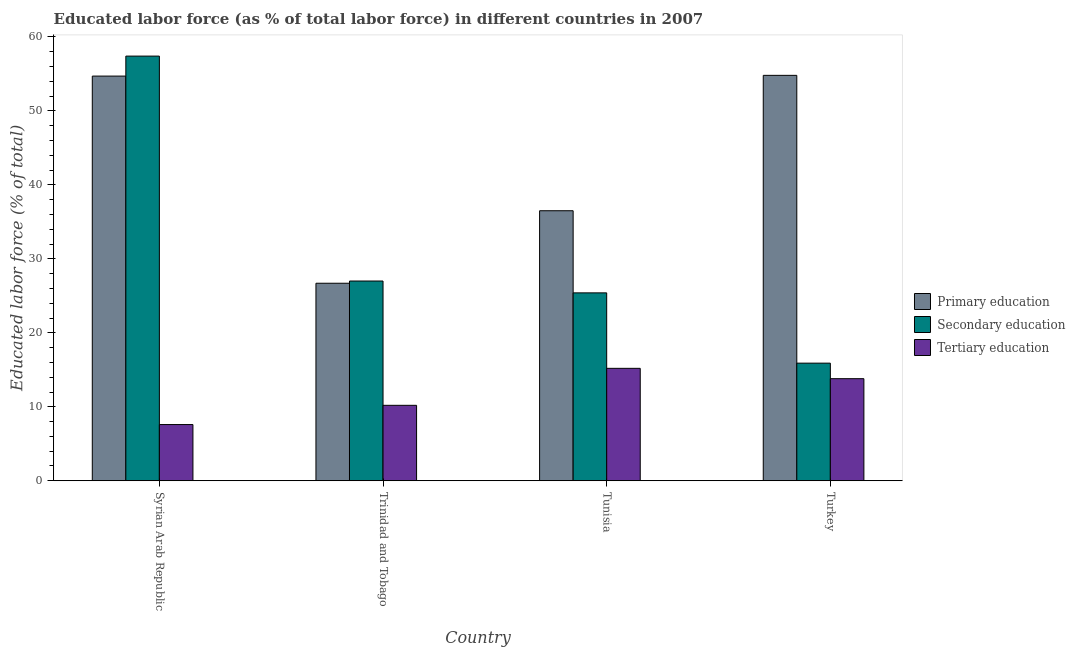How many different coloured bars are there?
Offer a terse response. 3. Are the number of bars per tick equal to the number of legend labels?
Keep it short and to the point. Yes. Are the number of bars on each tick of the X-axis equal?
Your answer should be compact. Yes. How many bars are there on the 4th tick from the left?
Your answer should be very brief. 3. What is the label of the 3rd group of bars from the left?
Your answer should be compact. Tunisia. In how many cases, is the number of bars for a given country not equal to the number of legend labels?
Offer a terse response. 0. What is the percentage of labor force who received primary education in Tunisia?
Your answer should be very brief. 36.5. Across all countries, what is the maximum percentage of labor force who received secondary education?
Offer a terse response. 57.4. Across all countries, what is the minimum percentage of labor force who received tertiary education?
Offer a terse response. 7.6. In which country was the percentage of labor force who received secondary education maximum?
Offer a very short reply. Syrian Arab Republic. What is the total percentage of labor force who received primary education in the graph?
Keep it short and to the point. 172.7. What is the difference between the percentage of labor force who received tertiary education in Trinidad and Tobago and that in Tunisia?
Offer a terse response. -5. What is the difference between the percentage of labor force who received primary education in Syrian Arab Republic and the percentage of labor force who received secondary education in Turkey?
Provide a succinct answer. 38.8. What is the average percentage of labor force who received secondary education per country?
Your answer should be compact. 31.43. What is the difference between the percentage of labor force who received secondary education and percentage of labor force who received primary education in Tunisia?
Provide a short and direct response. -11.1. In how many countries, is the percentage of labor force who received secondary education greater than 16 %?
Your answer should be very brief. 3. What is the ratio of the percentage of labor force who received primary education in Syrian Arab Republic to that in Trinidad and Tobago?
Keep it short and to the point. 2.05. Is the percentage of labor force who received tertiary education in Trinidad and Tobago less than that in Tunisia?
Offer a terse response. Yes. What is the difference between the highest and the second highest percentage of labor force who received primary education?
Your answer should be compact. 0.1. What is the difference between the highest and the lowest percentage of labor force who received primary education?
Your answer should be very brief. 28.1. In how many countries, is the percentage of labor force who received tertiary education greater than the average percentage of labor force who received tertiary education taken over all countries?
Your answer should be very brief. 2. Is the sum of the percentage of labor force who received secondary education in Tunisia and Turkey greater than the maximum percentage of labor force who received primary education across all countries?
Provide a short and direct response. No. What does the 2nd bar from the left in Trinidad and Tobago represents?
Provide a short and direct response. Secondary education. What does the 3rd bar from the right in Syrian Arab Republic represents?
Give a very brief answer. Primary education. Is it the case that in every country, the sum of the percentage of labor force who received primary education and percentage of labor force who received secondary education is greater than the percentage of labor force who received tertiary education?
Provide a short and direct response. Yes. How many bars are there?
Ensure brevity in your answer.  12. How many countries are there in the graph?
Provide a succinct answer. 4. Are the values on the major ticks of Y-axis written in scientific E-notation?
Keep it short and to the point. No. Where does the legend appear in the graph?
Your answer should be compact. Center right. How many legend labels are there?
Make the answer very short. 3. How are the legend labels stacked?
Provide a short and direct response. Vertical. What is the title of the graph?
Your response must be concise. Educated labor force (as % of total labor force) in different countries in 2007. What is the label or title of the Y-axis?
Provide a short and direct response. Educated labor force (% of total). What is the Educated labor force (% of total) in Primary education in Syrian Arab Republic?
Keep it short and to the point. 54.7. What is the Educated labor force (% of total) of Secondary education in Syrian Arab Republic?
Give a very brief answer. 57.4. What is the Educated labor force (% of total) in Tertiary education in Syrian Arab Republic?
Ensure brevity in your answer.  7.6. What is the Educated labor force (% of total) in Primary education in Trinidad and Tobago?
Make the answer very short. 26.7. What is the Educated labor force (% of total) in Tertiary education in Trinidad and Tobago?
Your response must be concise. 10.2. What is the Educated labor force (% of total) of Primary education in Tunisia?
Your response must be concise. 36.5. What is the Educated labor force (% of total) in Secondary education in Tunisia?
Give a very brief answer. 25.4. What is the Educated labor force (% of total) in Tertiary education in Tunisia?
Provide a short and direct response. 15.2. What is the Educated labor force (% of total) in Primary education in Turkey?
Make the answer very short. 54.8. What is the Educated labor force (% of total) of Secondary education in Turkey?
Your response must be concise. 15.9. What is the Educated labor force (% of total) in Tertiary education in Turkey?
Provide a succinct answer. 13.8. Across all countries, what is the maximum Educated labor force (% of total) in Primary education?
Your answer should be very brief. 54.8. Across all countries, what is the maximum Educated labor force (% of total) of Secondary education?
Give a very brief answer. 57.4. Across all countries, what is the maximum Educated labor force (% of total) in Tertiary education?
Provide a succinct answer. 15.2. Across all countries, what is the minimum Educated labor force (% of total) of Primary education?
Your response must be concise. 26.7. Across all countries, what is the minimum Educated labor force (% of total) of Secondary education?
Your response must be concise. 15.9. Across all countries, what is the minimum Educated labor force (% of total) in Tertiary education?
Ensure brevity in your answer.  7.6. What is the total Educated labor force (% of total) of Primary education in the graph?
Keep it short and to the point. 172.7. What is the total Educated labor force (% of total) of Secondary education in the graph?
Make the answer very short. 125.7. What is the total Educated labor force (% of total) of Tertiary education in the graph?
Offer a very short reply. 46.8. What is the difference between the Educated labor force (% of total) of Primary education in Syrian Arab Republic and that in Trinidad and Tobago?
Give a very brief answer. 28. What is the difference between the Educated labor force (% of total) in Secondary education in Syrian Arab Republic and that in Trinidad and Tobago?
Offer a very short reply. 30.4. What is the difference between the Educated labor force (% of total) of Tertiary education in Syrian Arab Republic and that in Trinidad and Tobago?
Ensure brevity in your answer.  -2.6. What is the difference between the Educated labor force (% of total) of Secondary education in Syrian Arab Republic and that in Tunisia?
Provide a short and direct response. 32. What is the difference between the Educated labor force (% of total) of Tertiary education in Syrian Arab Republic and that in Tunisia?
Your response must be concise. -7.6. What is the difference between the Educated labor force (% of total) in Secondary education in Syrian Arab Republic and that in Turkey?
Your response must be concise. 41.5. What is the difference between the Educated labor force (% of total) of Tertiary education in Trinidad and Tobago and that in Tunisia?
Provide a succinct answer. -5. What is the difference between the Educated labor force (% of total) of Primary education in Trinidad and Tobago and that in Turkey?
Provide a succinct answer. -28.1. What is the difference between the Educated labor force (% of total) of Secondary education in Trinidad and Tobago and that in Turkey?
Give a very brief answer. 11.1. What is the difference between the Educated labor force (% of total) of Tertiary education in Trinidad and Tobago and that in Turkey?
Offer a very short reply. -3.6. What is the difference between the Educated labor force (% of total) in Primary education in Tunisia and that in Turkey?
Keep it short and to the point. -18.3. What is the difference between the Educated labor force (% of total) of Secondary education in Tunisia and that in Turkey?
Your answer should be very brief. 9.5. What is the difference between the Educated labor force (% of total) of Primary education in Syrian Arab Republic and the Educated labor force (% of total) of Secondary education in Trinidad and Tobago?
Offer a very short reply. 27.7. What is the difference between the Educated labor force (% of total) of Primary education in Syrian Arab Republic and the Educated labor force (% of total) of Tertiary education in Trinidad and Tobago?
Make the answer very short. 44.5. What is the difference between the Educated labor force (% of total) of Secondary education in Syrian Arab Republic and the Educated labor force (% of total) of Tertiary education in Trinidad and Tobago?
Your answer should be compact. 47.2. What is the difference between the Educated labor force (% of total) in Primary education in Syrian Arab Republic and the Educated labor force (% of total) in Secondary education in Tunisia?
Offer a very short reply. 29.3. What is the difference between the Educated labor force (% of total) in Primary education in Syrian Arab Republic and the Educated labor force (% of total) in Tertiary education in Tunisia?
Offer a terse response. 39.5. What is the difference between the Educated labor force (% of total) in Secondary education in Syrian Arab Republic and the Educated labor force (% of total) in Tertiary education in Tunisia?
Make the answer very short. 42.2. What is the difference between the Educated labor force (% of total) in Primary education in Syrian Arab Republic and the Educated labor force (% of total) in Secondary education in Turkey?
Your answer should be very brief. 38.8. What is the difference between the Educated labor force (% of total) in Primary education in Syrian Arab Republic and the Educated labor force (% of total) in Tertiary education in Turkey?
Your response must be concise. 40.9. What is the difference between the Educated labor force (% of total) in Secondary education in Syrian Arab Republic and the Educated labor force (% of total) in Tertiary education in Turkey?
Give a very brief answer. 43.6. What is the difference between the Educated labor force (% of total) of Secondary education in Trinidad and Tobago and the Educated labor force (% of total) of Tertiary education in Tunisia?
Keep it short and to the point. 11.8. What is the difference between the Educated labor force (% of total) of Primary education in Trinidad and Tobago and the Educated labor force (% of total) of Secondary education in Turkey?
Make the answer very short. 10.8. What is the difference between the Educated labor force (% of total) of Secondary education in Trinidad and Tobago and the Educated labor force (% of total) of Tertiary education in Turkey?
Provide a short and direct response. 13.2. What is the difference between the Educated labor force (% of total) in Primary education in Tunisia and the Educated labor force (% of total) in Secondary education in Turkey?
Your answer should be very brief. 20.6. What is the difference between the Educated labor force (% of total) of Primary education in Tunisia and the Educated labor force (% of total) of Tertiary education in Turkey?
Keep it short and to the point. 22.7. What is the difference between the Educated labor force (% of total) of Secondary education in Tunisia and the Educated labor force (% of total) of Tertiary education in Turkey?
Offer a very short reply. 11.6. What is the average Educated labor force (% of total) of Primary education per country?
Offer a very short reply. 43.17. What is the average Educated labor force (% of total) in Secondary education per country?
Your answer should be compact. 31.43. What is the average Educated labor force (% of total) of Tertiary education per country?
Give a very brief answer. 11.7. What is the difference between the Educated labor force (% of total) of Primary education and Educated labor force (% of total) of Tertiary education in Syrian Arab Republic?
Provide a succinct answer. 47.1. What is the difference between the Educated labor force (% of total) in Secondary education and Educated labor force (% of total) in Tertiary education in Syrian Arab Republic?
Provide a succinct answer. 49.8. What is the difference between the Educated labor force (% of total) in Primary education and Educated labor force (% of total) in Secondary education in Trinidad and Tobago?
Your response must be concise. -0.3. What is the difference between the Educated labor force (% of total) of Primary education and Educated labor force (% of total) of Secondary education in Tunisia?
Keep it short and to the point. 11.1. What is the difference between the Educated labor force (% of total) in Primary education and Educated labor force (% of total) in Tertiary education in Tunisia?
Provide a short and direct response. 21.3. What is the difference between the Educated labor force (% of total) of Secondary education and Educated labor force (% of total) of Tertiary education in Tunisia?
Your response must be concise. 10.2. What is the difference between the Educated labor force (% of total) in Primary education and Educated labor force (% of total) in Secondary education in Turkey?
Provide a succinct answer. 38.9. What is the difference between the Educated labor force (% of total) in Primary education and Educated labor force (% of total) in Tertiary education in Turkey?
Ensure brevity in your answer.  41. What is the ratio of the Educated labor force (% of total) of Primary education in Syrian Arab Republic to that in Trinidad and Tobago?
Provide a short and direct response. 2.05. What is the ratio of the Educated labor force (% of total) in Secondary education in Syrian Arab Republic to that in Trinidad and Tobago?
Offer a terse response. 2.13. What is the ratio of the Educated labor force (% of total) in Tertiary education in Syrian Arab Republic to that in Trinidad and Tobago?
Provide a short and direct response. 0.75. What is the ratio of the Educated labor force (% of total) in Primary education in Syrian Arab Republic to that in Tunisia?
Provide a short and direct response. 1.5. What is the ratio of the Educated labor force (% of total) of Secondary education in Syrian Arab Republic to that in Tunisia?
Your answer should be very brief. 2.26. What is the ratio of the Educated labor force (% of total) of Primary education in Syrian Arab Republic to that in Turkey?
Keep it short and to the point. 1. What is the ratio of the Educated labor force (% of total) in Secondary education in Syrian Arab Republic to that in Turkey?
Make the answer very short. 3.61. What is the ratio of the Educated labor force (% of total) of Tertiary education in Syrian Arab Republic to that in Turkey?
Your answer should be compact. 0.55. What is the ratio of the Educated labor force (% of total) of Primary education in Trinidad and Tobago to that in Tunisia?
Keep it short and to the point. 0.73. What is the ratio of the Educated labor force (% of total) of Secondary education in Trinidad and Tobago to that in Tunisia?
Ensure brevity in your answer.  1.06. What is the ratio of the Educated labor force (% of total) in Tertiary education in Trinidad and Tobago to that in Tunisia?
Your response must be concise. 0.67. What is the ratio of the Educated labor force (% of total) of Primary education in Trinidad and Tobago to that in Turkey?
Ensure brevity in your answer.  0.49. What is the ratio of the Educated labor force (% of total) in Secondary education in Trinidad and Tobago to that in Turkey?
Your answer should be compact. 1.7. What is the ratio of the Educated labor force (% of total) in Tertiary education in Trinidad and Tobago to that in Turkey?
Offer a terse response. 0.74. What is the ratio of the Educated labor force (% of total) of Primary education in Tunisia to that in Turkey?
Your answer should be compact. 0.67. What is the ratio of the Educated labor force (% of total) in Secondary education in Tunisia to that in Turkey?
Keep it short and to the point. 1.6. What is the ratio of the Educated labor force (% of total) of Tertiary education in Tunisia to that in Turkey?
Make the answer very short. 1.1. What is the difference between the highest and the second highest Educated labor force (% of total) in Secondary education?
Offer a terse response. 30.4. What is the difference between the highest and the lowest Educated labor force (% of total) of Primary education?
Provide a short and direct response. 28.1. What is the difference between the highest and the lowest Educated labor force (% of total) in Secondary education?
Make the answer very short. 41.5. 